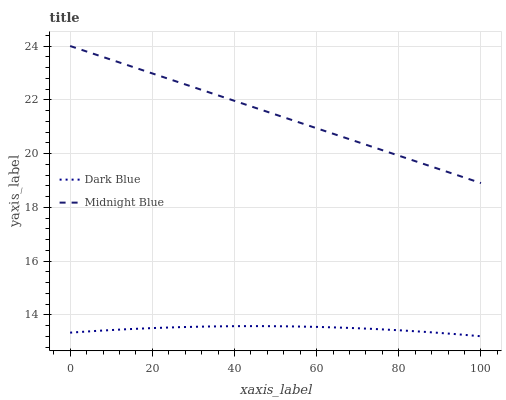Does Dark Blue have the minimum area under the curve?
Answer yes or no. Yes. Does Midnight Blue have the maximum area under the curve?
Answer yes or no. Yes. Does Midnight Blue have the minimum area under the curve?
Answer yes or no. No. Is Midnight Blue the smoothest?
Answer yes or no. Yes. Is Dark Blue the roughest?
Answer yes or no. Yes. Is Midnight Blue the roughest?
Answer yes or no. No. Does Dark Blue have the lowest value?
Answer yes or no. Yes. Does Midnight Blue have the lowest value?
Answer yes or no. No. Does Midnight Blue have the highest value?
Answer yes or no. Yes. Is Dark Blue less than Midnight Blue?
Answer yes or no. Yes. Is Midnight Blue greater than Dark Blue?
Answer yes or no. Yes. Does Dark Blue intersect Midnight Blue?
Answer yes or no. No. 